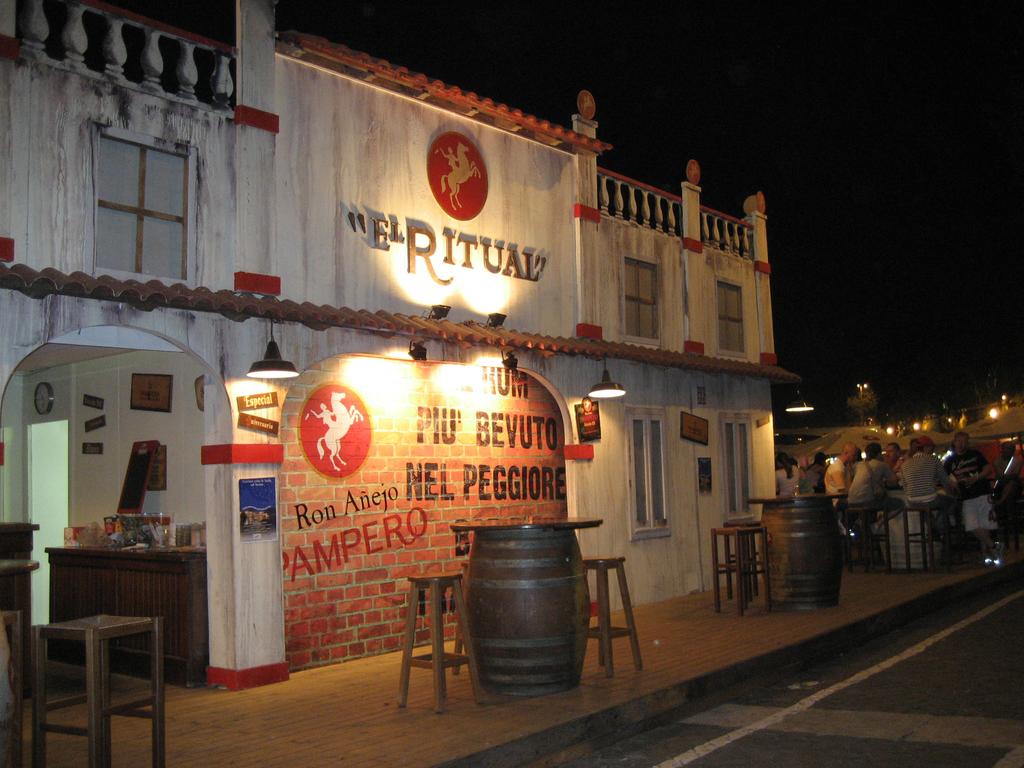What is the name of this place?
Your answer should be compact. El ritual. Is elritual a spanish restaurant?
Give a very brief answer. Unanswerable. 